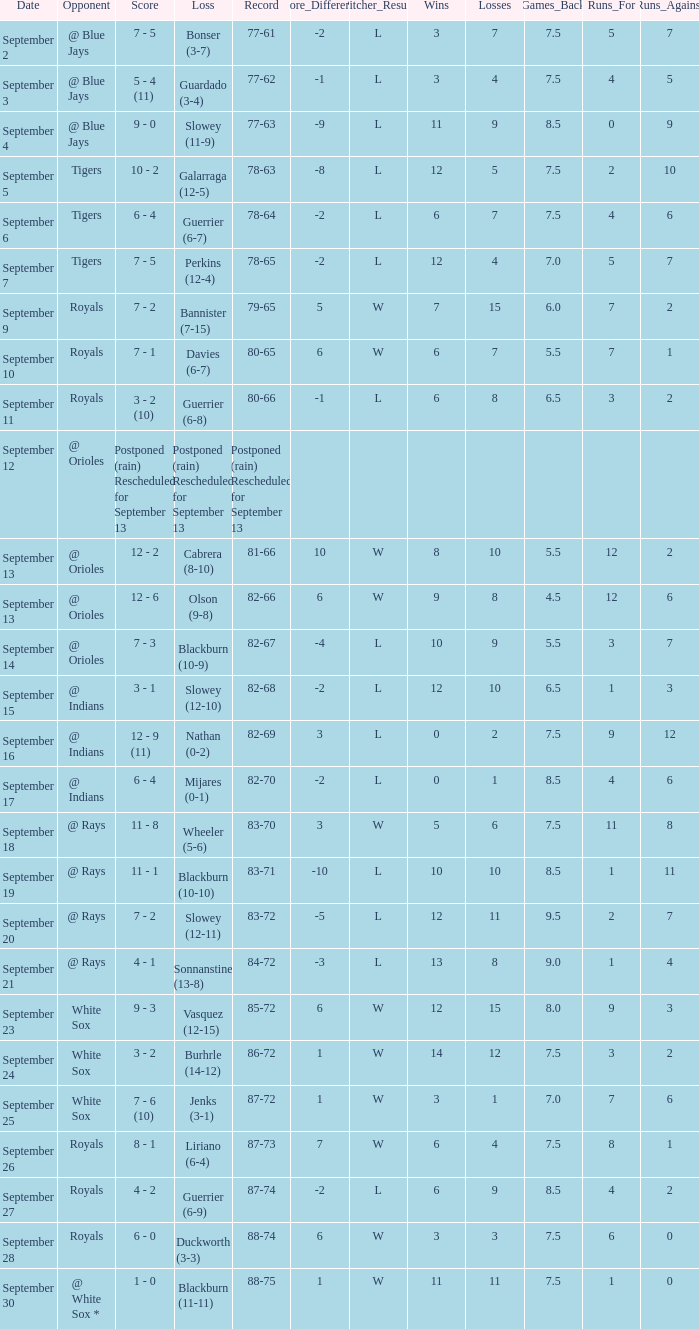What opponnent has a record of 82-68? @ Indians. 